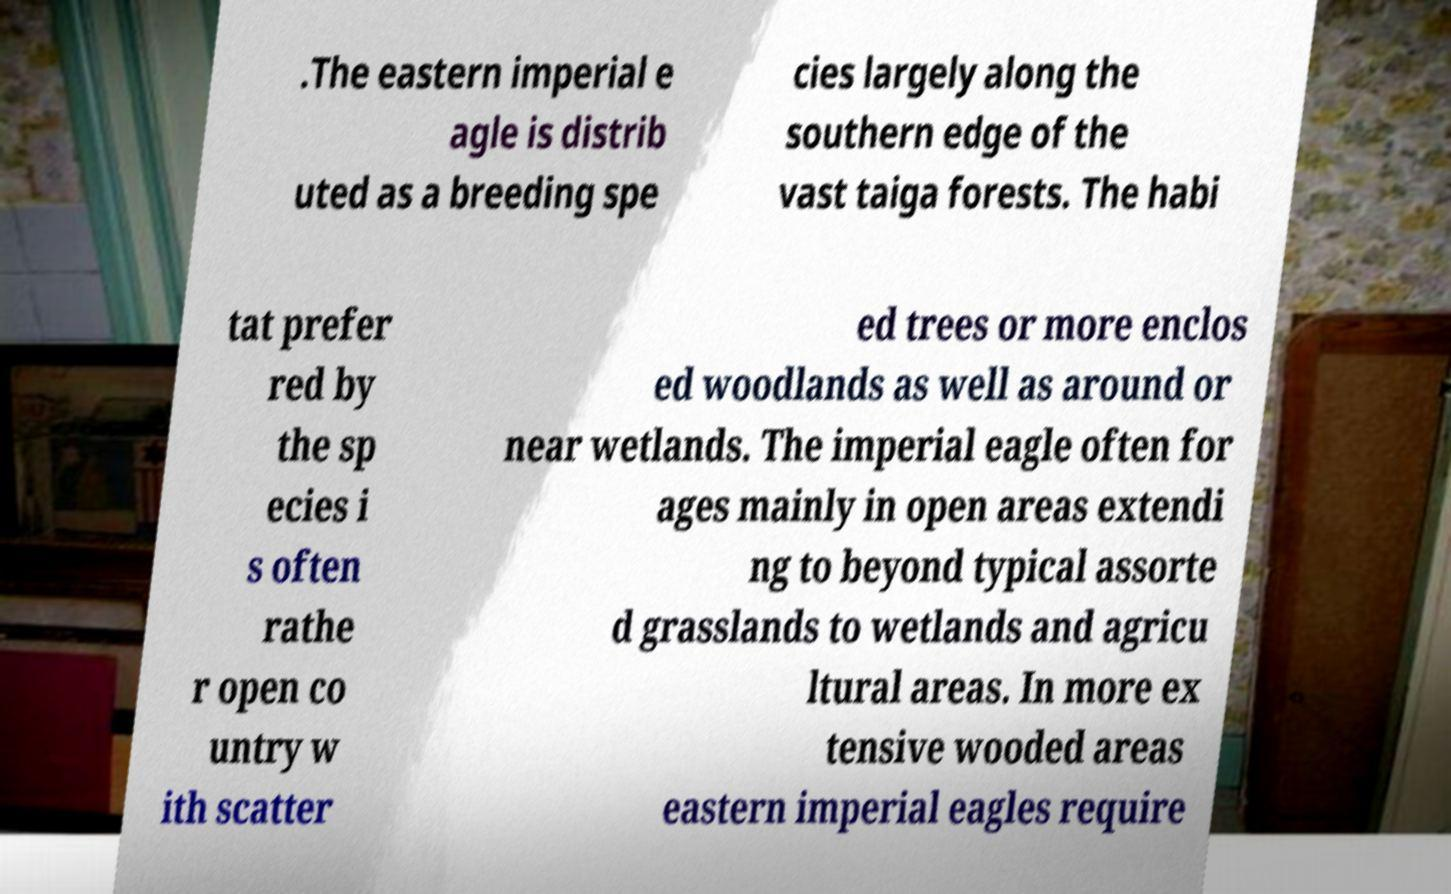Could you assist in decoding the text presented in this image and type it out clearly? .The eastern imperial e agle is distrib uted as a breeding spe cies largely along the southern edge of the vast taiga forests. The habi tat prefer red by the sp ecies i s often rathe r open co untry w ith scatter ed trees or more enclos ed woodlands as well as around or near wetlands. The imperial eagle often for ages mainly in open areas extendi ng to beyond typical assorte d grasslands to wetlands and agricu ltural areas. In more ex tensive wooded areas eastern imperial eagles require 